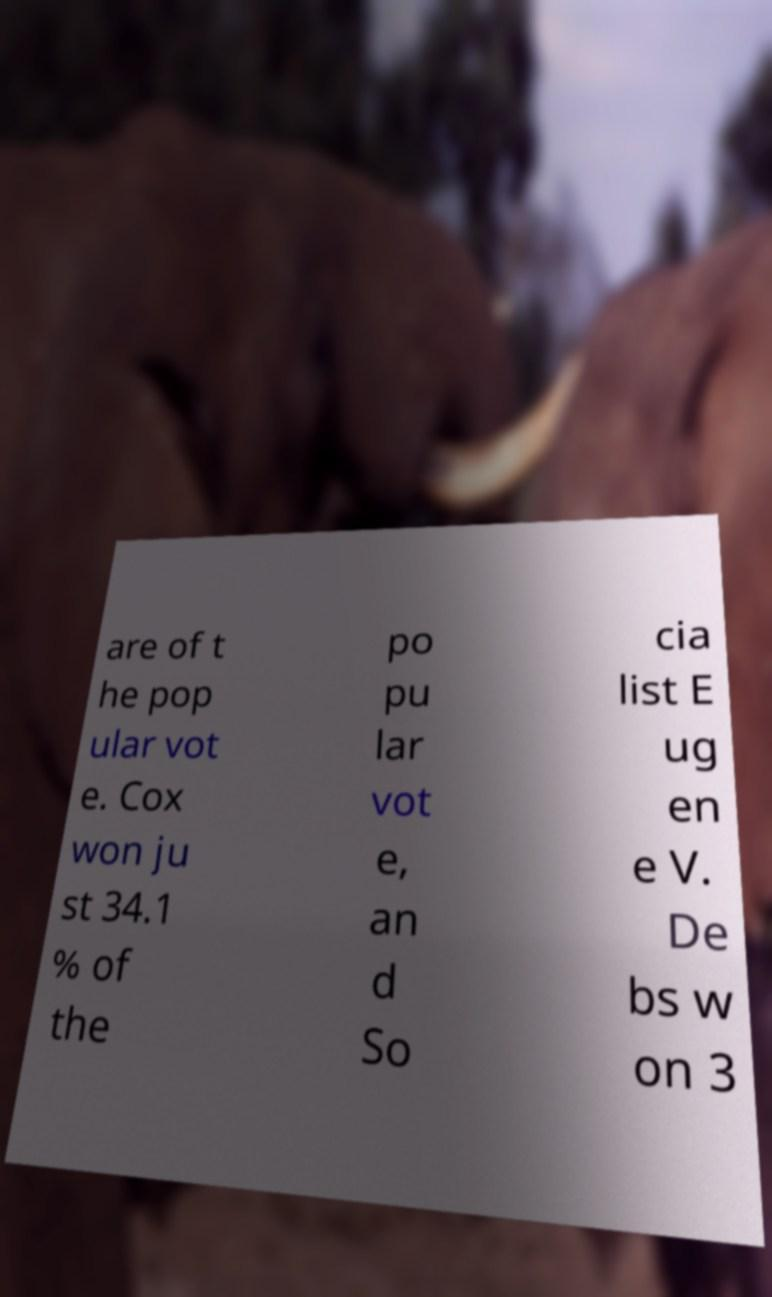What messages or text are displayed in this image? I need them in a readable, typed format. are of t he pop ular vot e. Cox won ju st 34.1 % of the po pu lar vot e, an d So cia list E ug en e V. De bs w on 3 